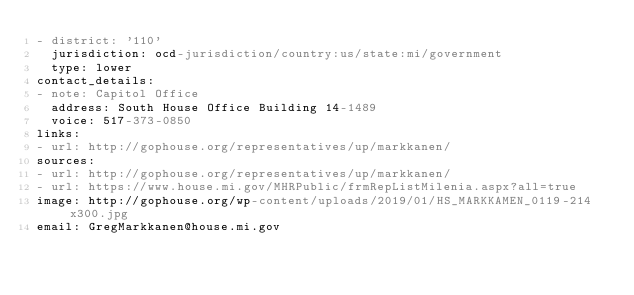<code> <loc_0><loc_0><loc_500><loc_500><_YAML_>- district: '110'
  jurisdiction: ocd-jurisdiction/country:us/state:mi/government
  type: lower
contact_details:
- note: Capitol Office
  address: South House Office Building 14-1489
  voice: 517-373-0850
links:
- url: http://gophouse.org/representatives/up/markkanen/
sources:
- url: http://gophouse.org/representatives/up/markkanen/
- url: https://www.house.mi.gov/MHRPublic/frmRepListMilenia.aspx?all=true
image: http://gophouse.org/wp-content/uploads/2019/01/HS_MARKKAMEN_0119-214x300.jpg
email: GregMarkkanen@house.mi.gov
</code> 